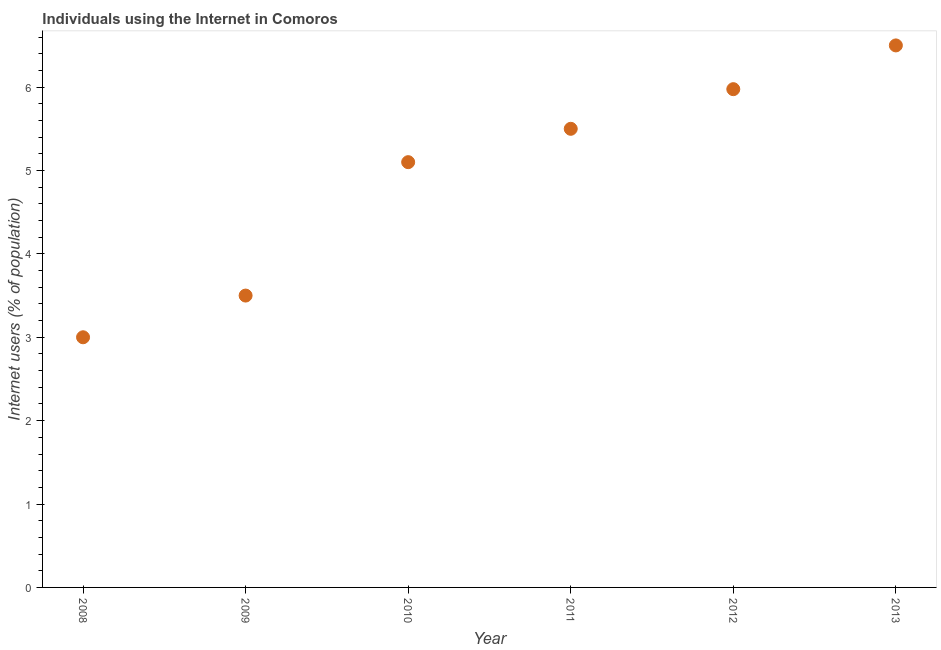Across all years, what is the maximum number of internet users?
Give a very brief answer. 6.5. What is the sum of the number of internet users?
Your answer should be compact. 29.58. What is the difference between the number of internet users in 2010 and 2013?
Give a very brief answer. -1.4. What is the average number of internet users per year?
Your answer should be compact. 4.93. What is the ratio of the number of internet users in 2008 to that in 2009?
Offer a terse response. 0.86. What is the difference between the highest and the second highest number of internet users?
Your response must be concise. 0.52. Does the number of internet users monotonically increase over the years?
Make the answer very short. Yes. What is the difference between two consecutive major ticks on the Y-axis?
Your answer should be very brief. 1. Are the values on the major ticks of Y-axis written in scientific E-notation?
Ensure brevity in your answer.  No. Does the graph contain grids?
Your response must be concise. No. What is the title of the graph?
Offer a terse response. Individuals using the Internet in Comoros. What is the label or title of the Y-axis?
Provide a short and direct response. Internet users (% of population). What is the Internet users (% of population) in 2010?
Keep it short and to the point. 5.1. What is the Internet users (% of population) in 2012?
Provide a succinct answer. 5.98. What is the Internet users (% of population) in 2013?
Keep it short and to the point. 6.5. What is the difference between the Internet users (% of population) in 2008 and 2011?
Ensure brevity in your answer.  -2.5. What is the difference between the Internet users (% of population) in 2008 and 2012?
Offer a terse response. -2.98. What is the difference between the Internet users (% of population) in 2009 and 2010?
Your response must be concise. -1.6. What is the difference between the Internet users (% of population) in 2009 and 2012?
Offer a very short reply. -2.48. What is the difference between the Internet users (% of population) in 2009 and 2013?
Make the answer very short. -3. What is the difference between the Internet users (% of population) in 2010 and 2012?
Provide a short and direct response. -0.88. What is the difference between the Internet users (% of population) in 2010 and 2013?
Ensure brevity in your answer.  -1.4. What is the difference between the Internet users (% of population) in 2011 and 2012?
Provide a short and direct response. -0.48. What is the difference between the Internet users (% of population) in 2011 and 2013?
Give a very brief answer. -1. What is the difference between the Internet users (% of population) in 2012 and 2013?
Ensure brevity in your answer.  -0.52. What is the ratio of the Internet users (% of population) in 2008 to that in 2009?
Your answer should be compact. 0.86. What is the ratio of the Internet users (% of population) in 2008 to that in 2010?
Make the answer very short. 0.59. What is the ratio of the Internet users (% of population) in 2008 to that in 2011?
Your answer should be compact. 0.55. What is the ratio of the Internet users (% of population) in 2008 to that in 2012?
Make the answer very short. 0.5. What is the ratio of the Internet users (% of population) in 2008 to that in 2013?
Offer a terse response. 0.46. What is the ratio of the Internet users (% of population) in 2009 to that in 2010?
Offer a very short reply. 0.69. What is the ratio of the Internet users (% of population) in 2009 to that in 2011?
Your answer should be compact. 0.64. What is the ratio of the Internet users (% of population) in 2009 to that in 2012?
Your response must be concise. 0.59. What is the ratio of the Internet users (% of population) in 2009 to that in 2013?
Offer a very short reply. 0.54. What is the ratio of the Internet users (% of population) in 2010 to that in 2011?
Ensure brevity in your answer.  0.93. What is the ratio of the Internet users (% of population) in 2010 to that in 2012?
Your answer should be compact. 0.85. What is the ratio of the Internet users (% of population) in 2010 to that in 2013?
Ensure brevity in your answer.  0.79. What is the ratio of the Internet users (% of population) in 2011 to that in 2012?
Give a very brief answer. 0.92. What is the ratio of the Internet users (% of population) in 2011 to that in 2013?
Provide a short and direct response. 0.85. What is the ratio of the Internet users (% of population) in 2012 to that in 2013?
Give a very brief answer. 0.92. 